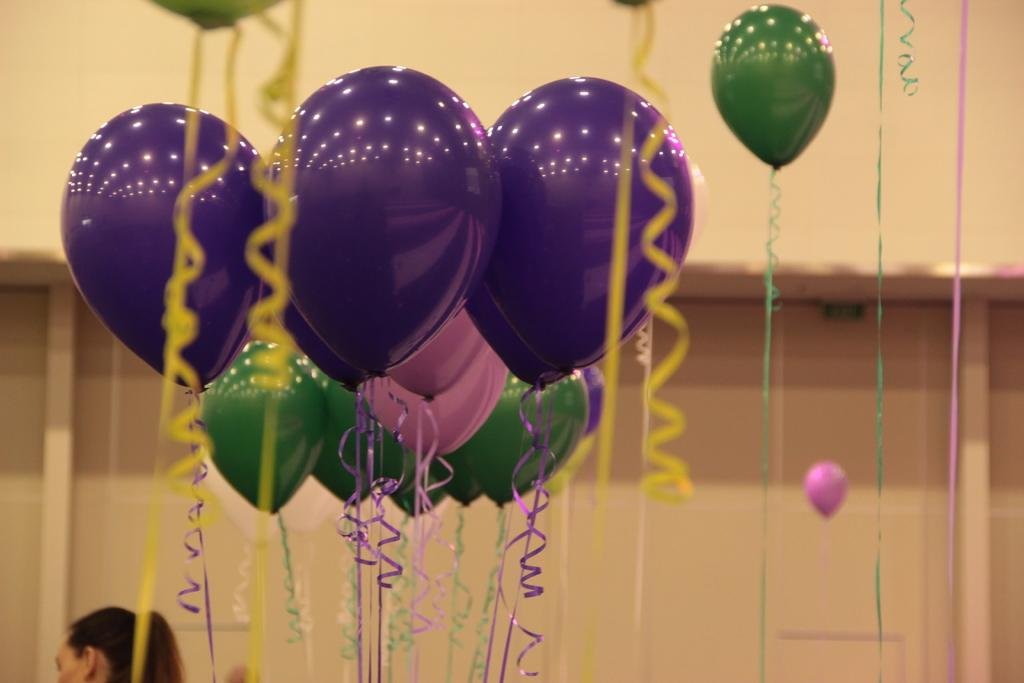What can be seen floating in the image? There are balloons in the image. What type of structure can be seen in the image? There are walls visible in the image. What type of material is used to decorate the balloons in the image? Satin ribbons are present in the image. What type of field is visible in the image? There is no field visible in the image; it features balloons, walls, and satin ribbons. 